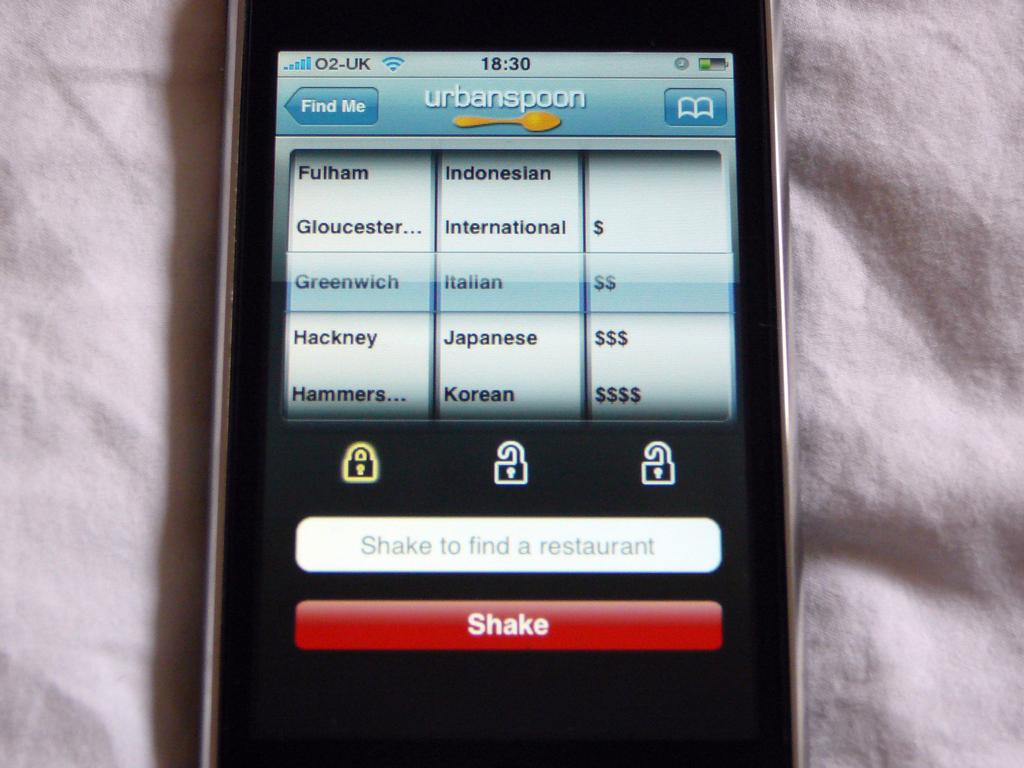<image>
Relay a brief, clear account of the picture shown. A smartphone is open to the urbanspoon with Greenwich Italian $$ highlighted and Shake as an option below. 